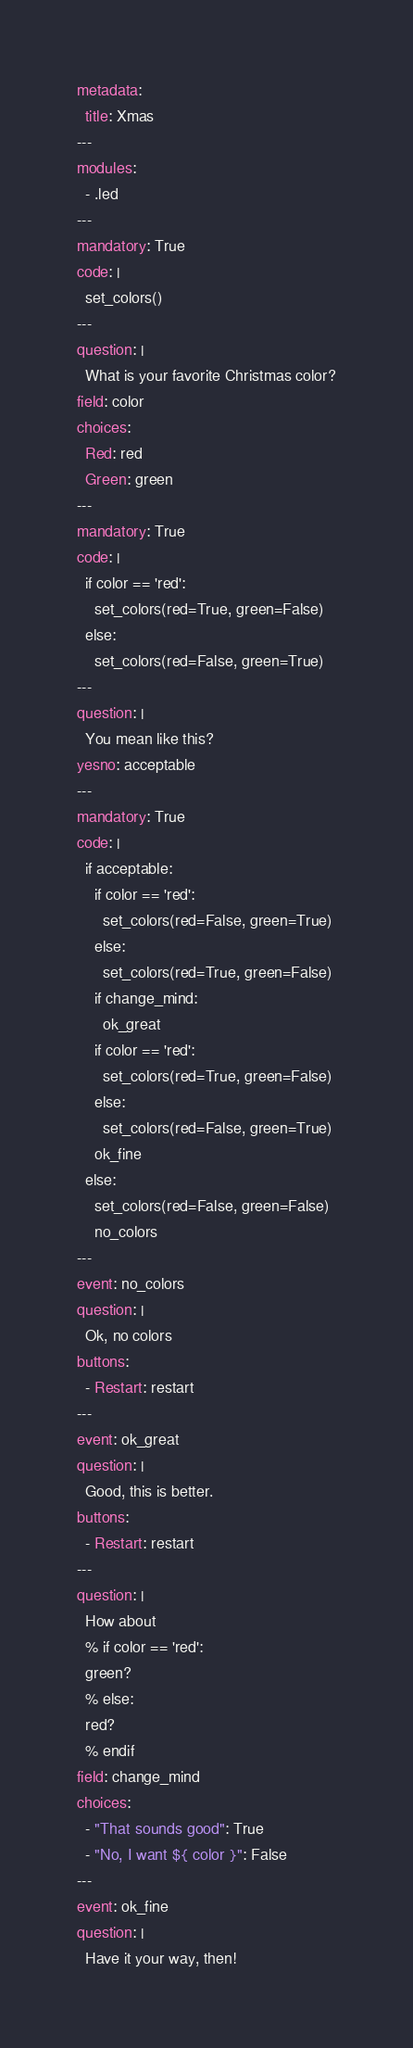Convert code to text. <code><loc_0><loc_0><loc_500><loc_500><_YAML_>metadata:
  title: Xmas
---
modules:
  - .led
---
mandatory: True
code: |
  set_colors()
---
question: |
  What is your favorite Christmas color?
field: color
choices:
  Red: red
  Green: green
---
mandatory: True
code: |
  if color == 'red':
    set_colors(red=True, green=False)
  else:
    set_colors(red=False, green=True)
---
question: |
  You mean like this?
yesno: acceptable
---
mandatory: True
code: |
  if acceptable:
    if color == 'red':
      set_colors(red=False, green=True)
    else:
      set_colors(red=True, green=False)
    if change_mind:
      ok_great
    if color == 'red':
      set_colors(red=True, green=False)
    else:
      set_colors(red=False, green=True)
    ok_fine
  else:
    set_colors(red=False, green=False)
    no_colors
---
event: no_colors
question: |
  Ok, no colors
buttons:
  - Restart: restart
---
event: ok_great
question: |
  Good, this is better.
buttons:
  - Restart: restart
---
question: |
  How about
  % if color == 'red':
  green?
  % else:
  red?
  % endif
field: change_mind
choices:
  - "That sounds good": True
  - "No, I want ${ color }": False
---
event: ok_fine
question: |
  Have it your way, then!</code> 